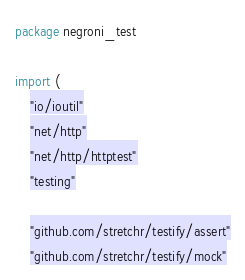Convert code to text. <code><loc_0><loc_0><loc_500><loc_500><_Go_>package negroni_test

import (
	"io/ioutil"
	"net/http"
	"net/http/httptest"
	"testing"

	"github.com/stretchr/testify/assert"
	"github.com/stretchr/testify/mock"</code> 